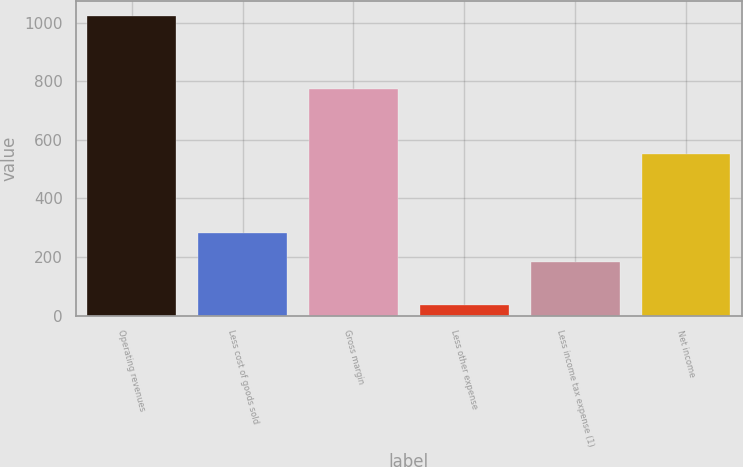Convert chart to OTSL. <chart><loc_0><loc_0><loc_500><loc_500><bar_chart><fcel>Operating revenues<fcel>Less cost of goods sold<fcel>Gross margin<fcel>Less other expense<fcel>Less income tax expense (1)<fcel>Net income<nl><fcel>1022<fcel>281.5<fcel>772<fcel>37<fcel>183<fcel>552<nl></chart> 